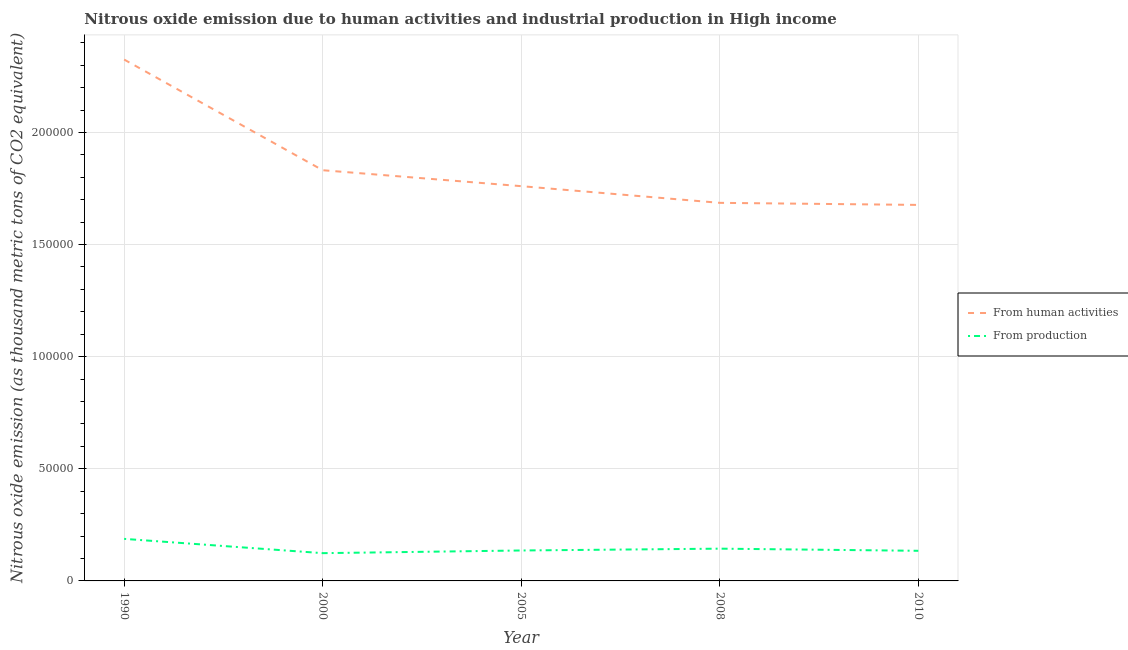How many different coloured lines are there?
Ensure brevity in your answer.  2. Does the line corresponding to amount of emissions generated from industries intersect with the line corresponding to amount of emissions from human activities?
Your answer should be very brief. No. Is the number of lines equal to the number of legend labels?
Your answer should be very brief. Yes. What is the amount of emissions generated from industries in 2010?
Your answer should be very brief. 1.34e+04. Across all years, what is the maximum amount of emissions generated from industries?
Offer a terse response. 1.88e+04. Across all years, what is the minimum amount of emissions from human activities?
Your answer should be very brief. 1.68e+05. In which year was the amount of emissions from human activities minimum?
Give a very brief answer. 2010. What is the total amount of emissions generated from industries in the graph?
Ensure brevity in your answer.  7.25e+04. What is the difference between the amount of emissions generated from industries in 1990 and that in 2010?
Give a very brief answer. 5319.5. What is the difference between the amount of emissions generated from industries in 2010 and the amount of emissions from human activities in 2000?
Your answer should be compact. -1.70e+05. What is the average amount of emissions generated from industries per year?
Your answer should be very brief. 1.45e+04. In the year 2005, what is the difference between the amount of emissions generated from industries and amount of emissions from human activities?
Your response must be concise. -1.62e+05. What is the ratio of the amount of emissions from human activities in 1990 to that in 2010?
Your response must be concise. 1.39. What is the difference between the highest and the second highest amount of emissions generated from industries?
Your answer should be very brief. 4366.8. What is the difference between the highest and the lowest amount of emissions from human activities?
Offer a terse response. 6.48e+04. In how many years, is the amount of emissions generated from industries greater than the average amount of emissions generated from industries taken over all years?
Your response must be concise. 1. Is the sum of the amount of emissions from human activities in 2000 and 2008 greater than the maximum amount of emissions generated from industries across all years?
Make the answer very short. Yes. Does the amount of emissions generated from industries monotonically increase over the years?
Offer a very short reply. No. Is the amount of emissions generated from industries strictly greater than the amount of emissions from human activities over the years?
Your answer should be very brief. No. Is the amount of emissions from human activities strictly less than the amount of emissions generated from industries over the years?
Keep it short and to the point. No. How many lines are there?
Offer a terse response. 2. How many years are there in the graph?
Offer a very short reply. 5. Are the values on the major ticks of Y-axis written in scientific E-notation?
Provide a succinct answer. No. Where does the legend appear in the graph?
Make the answer very short. Center right. How many legend labels are there?
Your answer should be very brief. 2. How are the legend labels stacked?
Your answer should be compact. Vertical. What is the title of the graph?
Provide a succinct answer. Nitrous oxide emission due to human activities and industrial production in High income. Does "Electricity" appear as one of the legend labels in the graph?
Give a very brief answer. No. What is the label or title of the Y-axis?
Your answer should be very brief. Nitrous oxide emission (as thousand metric tons of CO2 equivalent). What is the Nitrous oxide emission (as thousand metric tons of CO2 equivalent) in From human activities in 1990?
Offer a terse response. 2.33e+05. What is the Nitrous oxide emission (as thousand metric tons of CO2 equivalent) in From production in 1990?
Ensure brevity in your answer.  1.88e+04. What is the Nitrous oxide emission (as thousand metric tons of CO2 equivalent) of From human activities in 2000?
Your answer should be very brief. 1.83e+05. What is the Nitrous oxide emission (as thousand metric tons of CO2 equivalent) of From production in 2000?
Provide a succinct answer. 1.24e+04. What is the Nitrous oxide emission (as thousand metric tons of CO2 equivalent) in From human activities in 2005?
Your response must be concise. 1.76e+05. What is the Nitrous oxide emission (as thousand metric tons of CO2 equivalent) of From production in 2005?
Offer a very short reply. 1.36e+04. What is the Nitrous oxide emission (as thousand metric tons of CO2 equivalent) in From human activities in 2008?
Your answer should be compact. 1.69e+05. What is the Nitrous oxide emission (as thousand metric tons of CO2 equivalent) in From production in 2008?
Ensure brevity in your answer.  1.44e+04. What is the Nitrous oxide emission (as thousand metric tons of CO2 equivalent) of From human activities in 2010?
Offer a very short reply. 1.68e+05. What is the Nitrous oxide emission (as thousand metric tons of CO2 equivalent) of From production in 2010?
Give a very brief answer. 1.34e+04. Across all years, what is the maximum Nitrous oxide emission (as thousand metric tons of CO2 equivalent) of From human activities?
Ensure brevity in your answer.  2.33e+05. Across all years, what is the maximum Nitrous oxide emission (as thousand metric tons of CO2 equivalent) in From production?
Keep it short and to the point. 1.88e+04. Across all years, what is the minimum Nitrous oxide emission (as thousand metric tons of CO2 equivalent) in From human activities?
Give a very brief answer. 1.68e+05. Across all years, what is the minimum Nitrous oxide emission (as thousand metric tons of CO2 equivalent) in From production?
Offer a very short reply. 1.24e+04. What is the total Nitrous oxide emission (as thousand metric tons of CO2 equivalent) in From human activities in the graph?
Offer a terse response. 9.28e+05. What is the total Nitrous oxide emission (as thousand metric tons of CO2 equivalent) of From production in the graph?
Your response must be concise. 7.25e+04. What is the difference between the Nitrous oxide emission (as thousand metric tons of CO2 equivalent) in From human activities in 1990 and that in 2000?
Make the answer very short. 4.94e+04. What is the difference between the Nitrous oxide emission (as thousand metric tons of CO2 equivalent) in From production in 1990 and that in 2000?
Make the answer very short. 6373.1. What is the difference between the Nitrous oxide emission (as thousand metric tons of CO2 equivalent) in From human activities in 1990 and that in 2005?
Ensure brevity in your answer.  5.65e+04. What is the difference between the Nitrous oxide emission (as thousand metric tons of CO2 equivalent) of From production in 1990 and that in 2005?
Offer a terse response. 5181.3. What is the difference between the Nitrous oxide emission (as thousand metric tons of CO2 equivalent) in From human activities in 1990 and that in 2008?
Give a very brief answer. 6.39e+04. What is the difference between the Nitrous oxide emission (as thousand metric tons of CO2 equivalent) in From production in 1990 and that in 2008?
Provide a short and direct response. 4366.8. What is the difference between the Nitrous oxide emission (as thousand metric tons of CO2 equivalent) of From human activities in 1990 and that in 2010?
Offer a very short reply. 6.48e+04. What is the difference between the Nitrous oxide emission (as thousand metric tons of CO2 equivalent) in From production in 1990 and that in 2010?
Provide a succinct answer. 5319.5. What is the difference between the Nitrous oxide emission (as thousand metric tons of CO2 equivalent) in From human activities in 2000 and that in 2005?
Offer a terse response. 7109.4. What is the difference between the Nitrous oxide emission (as thousand metric tons of CO2 equivalent) in From production in 2000 and that in 2005?
Your answer should be very brief. -1191.8. What is the difference between the Nitrous oxide emission (as thousand metric tons of CO2 equivalent) in From human activities in 2000 and that in 2008?
Offer a very short reply. 1.45e+04. What is the difference between the Nitrous oxide emission (as thousand metric tons of CO2 equivalent) in From production in 2000 and that in 2008?
Provide a short and direct response. -2006.3. What is the difference between the Nitrous oxide emission (as thousand metric tons of CO2 equivalent) in From human activities in 2000 and that in 2010?
Provide a short and direct response. 1.55e+04. What is the difference between the Nitrous oxide emission (as thousand metric tons of CO2 equivalent) in From production in 2000 and that in 2010?
Your answer should be compact. -1053.6. What is the difference between the Nitrous oxide emission (as thousand metric tons of CO2 equivalent) in From human activities in 2005 and that in 2008?
Offer a terse response. 7440. What is the difference between the Nitrous oxide emission (as thousand metric tons of CO2 equivalent) in From production in 2005 and that in 2008?
Give a very brief answer. -814.5. What is the difference between the Nitrous oxide emission (as thousand metric tons of CO2 equivalent) of From human activities in 2005 and that in 2010?
Your response must be concise. 8364.9. What is the difference between the Nitrous oxide emission (as thousand metric tons of CO2 equivalent) of From production in 2005 and that in 2010?
Ensure brevity in your answer.  138.2. What is the difference between the Nitrous oxide emission (as thousand metric tons of CO2 equivalent) of From human activities in 2008 and that in 2010?
Your response must be concise. 924.9. What is the difference between the Nitrous oxide emission (as thousand metric tons of CO2 equivalent) of From production in 2008 and that in 2010?
Make the answer very short. 952.7. What is the difference between the Nitrous oxide emission (as thousand metric tons of CO2 equivalent) of From human activities in 1990 and the Nitrous oxide emission (as thousand metric tons of CO2 equivalent) of From production in 2000?
Offer a very short reply. 2.20e+05. What is the difference between the Nitrous oxide emission (as thousand metric tons of CO2 equivalent) of From human activities in 1990 and the Nitrous oxide emission (as thousand metric tons of CO2 equivalent) of From production in 2005?
Give a very brief answer. 2.19e+05. What is the difference between the Nitrous oxide emission (as thousand metric tons of CO2 equivalent) of From human activities in 1990 and the Nitrous oxide emission (as thousand metric tons of CO2 equivalent) of From production in 2008?
Ensure brevity in your answer.  2.18e+05. What is the difference between the Nitrous oxide emission (as thousand metric tons of CO2 equivalent) of From human activities in 1990 and the Nitrous oxide emission (as thousand metric tons of CO2 equivalent) of From production in 2010?
Make the answer very short. 2.19e+05. What is the difference between the Nitrous oxide emission (as thousand metric tons of CO2 equivalent) of From human activities in 2000 and the Nitrous oxide emission (as thousand metric tons of CO2 equivalent) of From production in 2005?
Provide a short and direct response. 1.70e+05. What is the difference between the Nitrous oxide emission (as thousand metric tons of CO2 equivalent) of From human activities in 2000 and the Nitrous oxide emission (as thousand metric tons of CO2 equivalent) of From production in 2008?
Offer a terse response. 1.69e+05. What is the difference between the Nitrous oxide emission (as thousand metric tons of CO2 equivalent) in From human activities in 2000 and the Nitrous oxide emission (as thousand metric tons of CO2 equivalent) in From production in 2010?
Your answer should be very brief. 1.70e+05. What is the difference between the Nitrous oxide emission (as thousand metric tons of CO2 equivalent) in From human activities in 2005 and the Nitrous oxide emission (as thousand metric tons of CO2 equivalent) in From production in 2008?
Keep it short and to the point. 1.62e+05. What is the difference between the Nitrous oxide emission (as thousand metric tons of CO2 equivalent) in From human activities in 2005 and the Nitrous oxide emission (as thousand metric tons of CO2 equivalent) in From production in 2010?
Offer a very short reply. 1.63e+05. What is the difference between the Nitrous oxide emission (as thousand metric tons of CO2 equivalent) in From human activities in 2008 and the Nitrous oxide emission (as thousand metric tons of CO2 equivalent) in From production in 2010?
Give a very brief answer. 1.55e+05. What is the average Nitrous oxide emission (as thousand metric tons of CO2 equivalent) in From human activities per year?
Offer a very short reply. 1.86e+05. What is the average Nitrous oxide emission (as thousand metric tons of CO2 equivalent) of From production per year?
Provide a short and direct response. 1.45e+04. In the year 1990, what is the difference between the Nitrous oxide emission (as thousand metric tons of CO2 equivalent) of From human activities and Nitrous oxide emission (as thousand metric tons of CO2 equivalent) of From production?
Keep it short and to the point. 2.14e+05. In the year 2000, what is the difference between the Nitrous oxide emission (as thousand metric tons of CO2 equivalent) in From human activities and Nitrous oxide emission (as thousand metric tons of CO2 equivalent) in From production?
Provide a short and direct response. 1.71e+05. In the year 2005, what is the difference between the Nitrous oxide emission (as thousand metric tons of CO2 equivalent) in From human activities and Nitrous oxide emission (as thousand metric tons of CO2 equivalent) in From production?
Offer a terse response. 1.62e+05. In the year 2008, what is the difference between the Nitrous oxide emission (as thousand metric tons of CO2 equivalent) of From human activities and Nitrous oxide emission (as thousand metric tons of CO2 equivalent) of From production?
Your answer should be compact. 1.54e+05. In the year 2010, what is the difference between the Nitrous oxide emission (as thousand metric tons of CO2 equivalent) in From human activities and Nitrous oxide emission (as thousand metric tons of CO2 equivalent) in From production?
Provide a short and direct response. 1.54e+05. What is the ratio of the Nitrous oxide emission (as thousand metric tons of CO2 equivalent) in From human activities in 1990 to that in 2000?
Give a very brief answer. 1.27. What is the ratio of the Nitrous oxide emission (as thousand metric tons of CO2 equivalent) of From production in 1990 to that in 2000?
Your answer should be compact. 1.51. What is the ratio of the Nitrous oxide emission (as thousand metric tons of CO2 equivalent) in From human activities in 1990 to that in 2005?
Your response must be concise. 1.32. What is the ratio of the Nitrous oxide emission (as thousand metric tons of CO2 equivalent) of From production in 1990 to that in 2005?
Offer a terse response. 1.38. What is the ratio of the Nitrous oxide emission (as thousand metric tons of CO2 equivalent) of From human activities in 1990 to that in 2008?
Provide a succinct answer. 1.38. What is the ratio of the Nitrous oxide emission (as thousand metric tons of CO2 equivalent) of From production in 1990 to that in 2008?
Ensure brevity in your answer.  1.3. What is the ratio of the Nitrous oxide emission (as thousand metric tons of CO2 equivalent) of From human activities in 1990 to that in 2010?
Ensure brevity in your answer.  1.39. What is the ratio of the Nitrous oxide emission (as thousand metric tons of CO2 equivalent) in From production in 1990 to that in 2010?
Your answer should be compact. 1.4. What is the ratio of the Nitrous oxide emission (as thousand metric tons of CO2 equivalent) in From human activities in 2000 to that in 2005?
Give a very brief answer. 1.04. What is the ratio of the Nitrous oxide emission (as thousand metric tons of CO2 equivalent) in From production in 2000 to that in 2005?
Your answer should be compact. 0.91. What is the ratio of the Nitrous oxide emission (as thousand metric tons of CO2 equivalent) of From human activities in 2000 to that in 2008?
Give a very brief answer. 1.09. What is the ratio of the Nitrous oxide emission (as thousand metric tons of CO2 equivalent) in From production in 2000 to that in 2008?
Your answer should be very brief. 0.86. What is the ratio of the Nitrous oxide emission (as thousand metric tons of CO2 equivalent) of From human activities in 2000 to that in 2010?
Offer a very short reply. 1.09. What is the ratio of the Nitrous oxide emission (as thousand metric tons of CO2 equivalent) of From production in 2000 to that in 2010?
Offer a terse response. 0.92. What is the ratio of the Nitrous oxide emission (as thousand metric tons of CO2 equivalent) in From human activities in 2005 to that in 2008?
Ensure brevity in your answer.  1.04. What is the ratio of the Nitrous oxide emission (as thousand metric tons of CO2 equivalent) in From production in 2005 to that in 2008?
Provide a short and direct response. 0.94. What is the ratio of the Nitrous oxide emission (as thousand metric tons of CO2 equivalent) in From human activities in 2005 to that in 2010?
Your answer should be compact. 1.05. What is the ratio of the Nitrous oxide emission (as thousand metric tons of CO2 equivalent) of From production in 2005 to that in 2010?
Offer a terse response. 1.01. What is the ratio of the Nitrous oxide emission (as thousand metric tons of CO2 equivalent) of From production in 2008 to that in 2010?
Ensure brevity in your answer.  1.07. What is the difference between the highest and the second highest Nitrous oxide emission (as thousand metric tons of CO2 equivalent) in From human activities?
Give a very brief answer. 4.94e+04. What is the difference between the highest and the second highest Nitrous oxide emission (as thousand metric tons of CO2 equivalent) in From production?
Keep it short and to the point. 4366.8. What is the difference between the highest and the lowest Nitrous oxide emission (as thousand metric tons of CO2 equivalent) of From human activities?
Keep it short and to the point. 6.48e+04. What is the difference between the highest and the lowest Nitrous oxide emission (as thousand metric tons of CO2 equivalent) in From production?
Keep it short and to the point. 6373.1. 